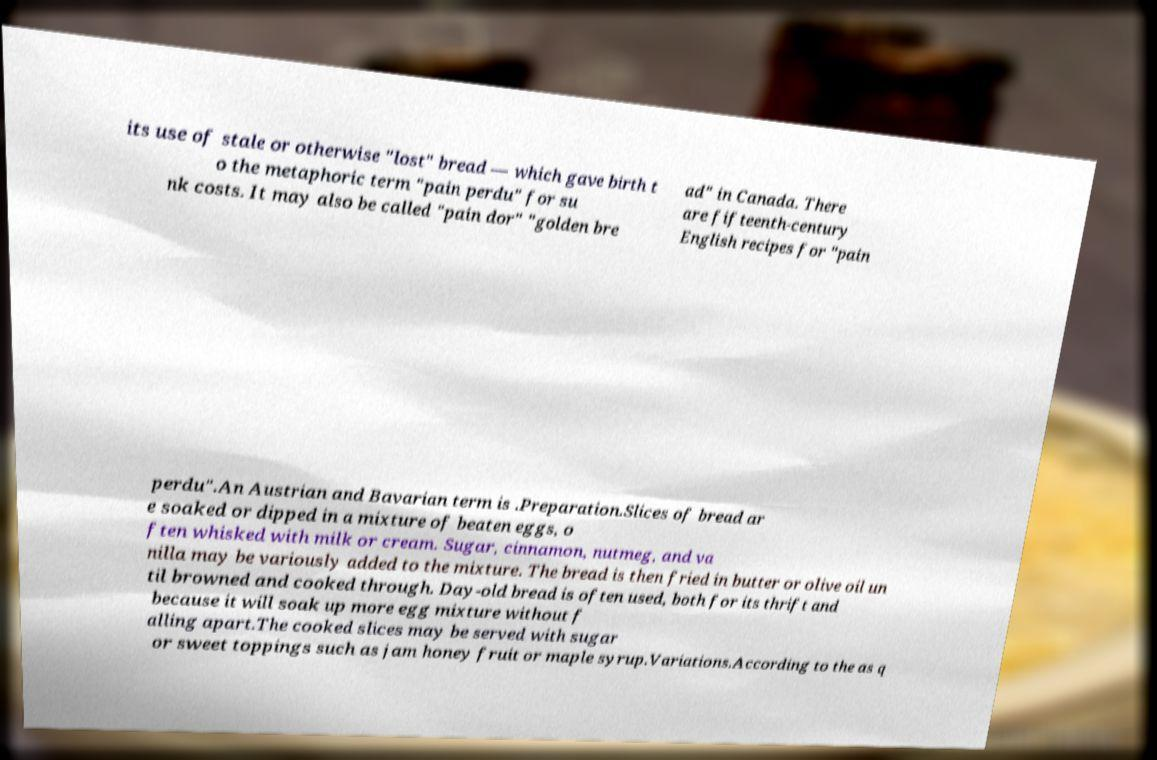There's text embedded in this image that I need extracted. Can you transcribe it verbatim? its use of stale or otherwise "lost" bread — which gave birth t o the metaphoric term "pain perdu" for su nk costs. It may also be called "pain dor" "golden bre ad" in Canada. There are fifteenth-century English recipes for "pain perdu".An Austrian and Bavarian term is .Preparation.Slices of bread ar e soaked or dipped in a mixture of beaten eggs, o ften whisked with milk or cream. Sugar, cinnamon, nutmeg, and va nilla may be variously added to the mixture. The bread is then fried in butter or olive oil un til browned and cooked through. Day-old bread is often used, both for its thrift and because it will soak up more egg mixture without f alling apart.The cooked slices may be served with sugar or sweet toppings such as jam honey fruit or maple syrup.Variations.According to the as q 